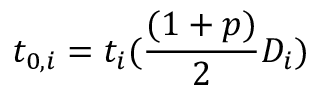<formula> <loc_0><loc_0><loc_500><loc_500>t _ { 0 , i } = t _ { i } ( \frac { ( 1 + p ) } { 2 } D _ { i } )</formula> 